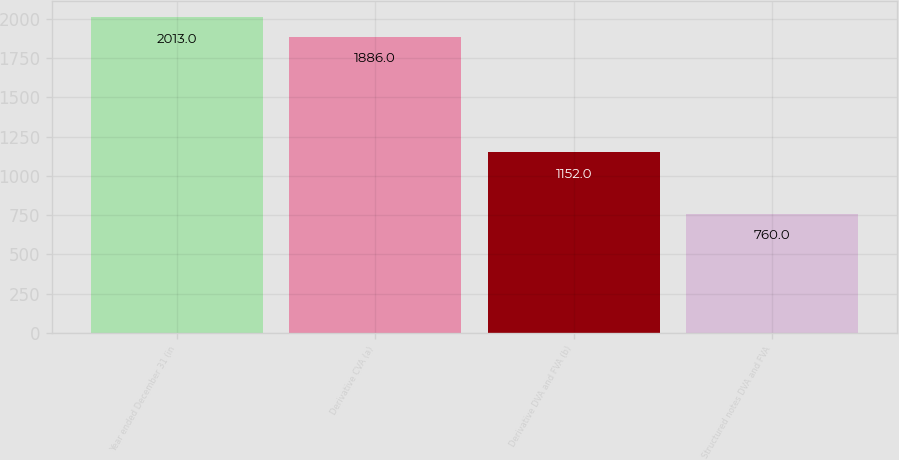Convert chart to OTSL. <chart><loc_0><loc_0><loc_500><loc_500><bar_chart><fcel>Year ended December 31 (in<fcel>Derivative CVA (a)<fcel>Derivative DVA and FVA (b)<fcel>Structured notes DVA and FVA<nl><fcel>2013<fcel>1886<fcel>1152<fcel>760<nl></chart> 